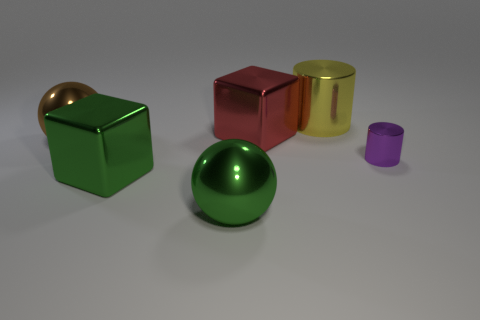Subtract all cyan balls. Subtract all cyan blocks. How many balls are left? 2 Add 4 large green cubes. How many objects exist? 10 Subtract all cubes. How many objects are left? 4 Add 2 small purple spheres. How many small purple spheres exist? 2 Subtract 0 cyan balls. How many objects are left? 6 Subtract all big metal blocks. Subtract all tiny purple metal cylinders. How many objects are left? 3 Add 3 purple metal things. How many purple metal things are left? 4 